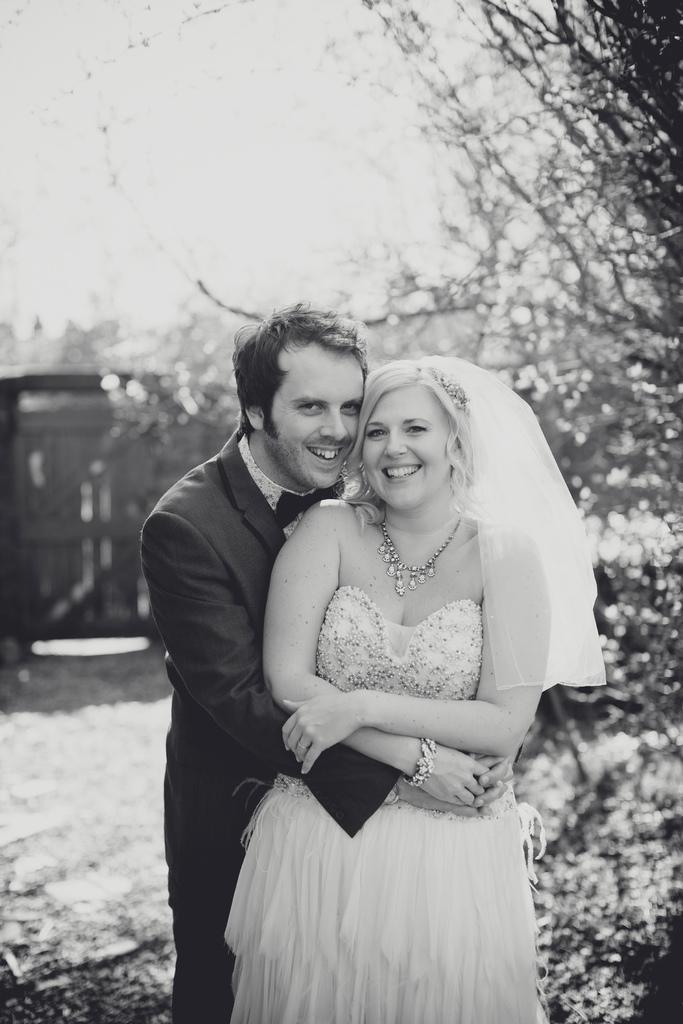Can you describe this image briefly? In this picture we can see a man and a woman standing and smiling, trees and in the background we can see the sky and it is blurry. 